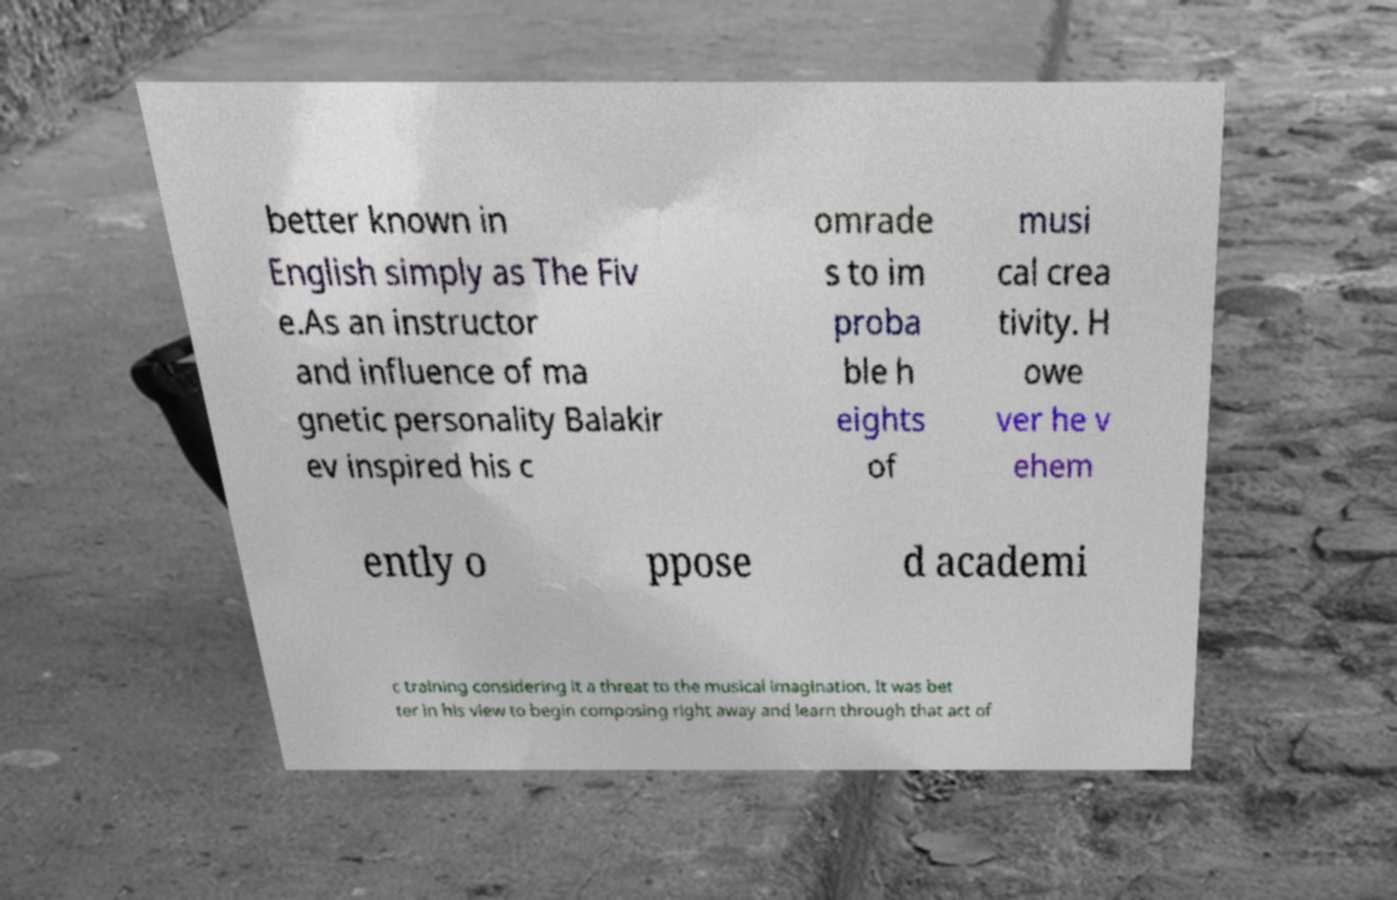For documentation purposes, I need the text within this image transcribed. Could you provide that? better known in English simply as The Fiv e.As an instructor and influence of ma gnetic personality Balakir ev inspired his c omrade s to im proba ble h eights of musi cal crea tivity. H owe ver he v ehem ently o ppose d academi c training considering it a threat to the musical imagination. It was bet ter in his view to begin composing right away and learn through that act of 